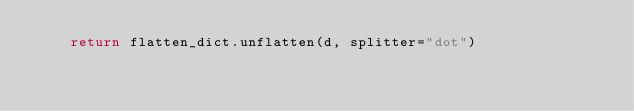<code> <loc_0><loc_0><loc_500><loc_500><_Python_>    return flatten_dict.unflatten(d, splitter="dot")
</code> 